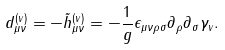<formula> <loc_0><loc_0><loc_500><loc_500>d ^ { ( v ) } _ { \mu \nu } = - \tilde { h } ^ { ( v ) } _ { \mu \nu } = - \frac { 1 } { g } \epsilon _ { \mu \nu \rho \sigma } \partial _ { \rho } \partial _ { \sigma } \gamma _ { v } .</formula> 